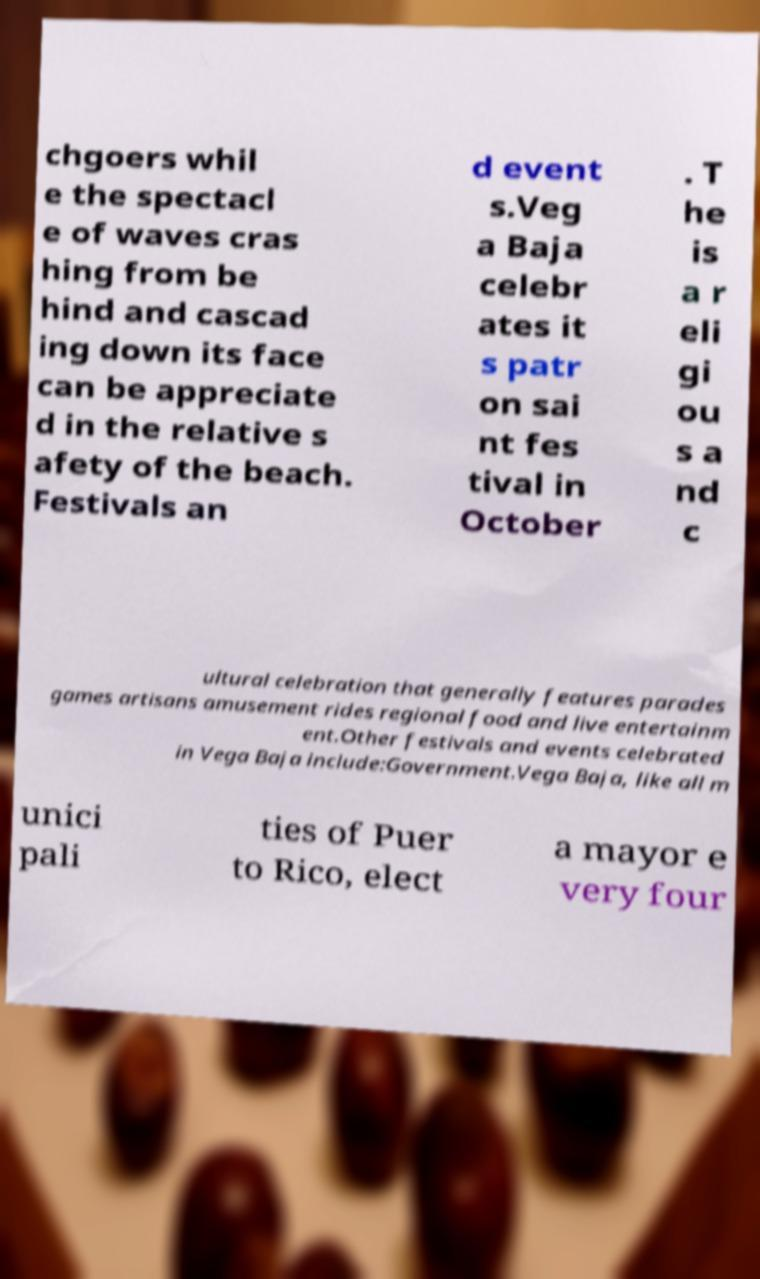Can you read and provide the text displayed in the image?This photo seems to have some interesting text. Can you extract and type it out for me? chgoers whil e the spectacl e of waves cras hing from be hind and cascad ing down its face can be appreciate d in the relative s afety of the beach. Festivals an d event s.Veg a Baja celebr ates it s patr on sai nt fes tival in October . T he is a r eli gi ou s a nd c ultural celebration that generally features parades games artisans amusement rides regional food and live entertainm ent.Other festivals and events celebrated in Vega Baja include:Government.Vega Baja, like all m unici pali ties of Puer to Rico, elect a mayor e very four 